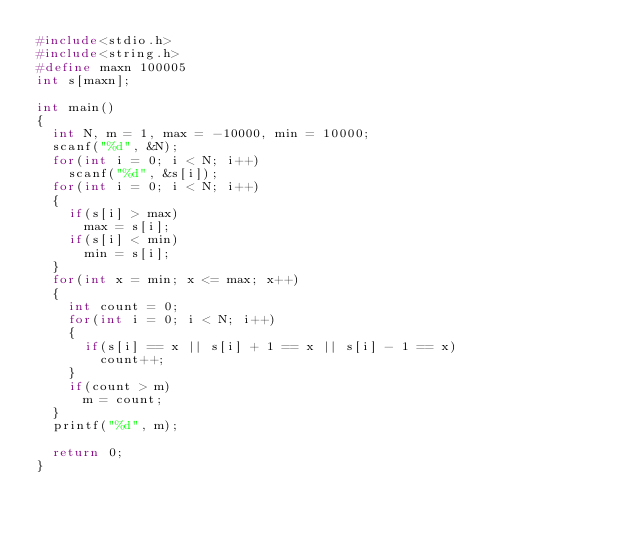<code> <loc_0><loc_0><loc_500><loc_500><_C_>#include<stdio.h>
#include<string.h>
#define maxn 100005
int s[maxn];

int main()
{
	int N, m = 1, max = -10000, min = 10000;
	scanf("%d", &N);
	for(int i = 0; i < N; i++)
		scanf("%d", &s[i]);
	for(int i = 0; i < N; i++)
	{
		if(s[i] > max)
			max = s[i];
		if(s[i] < min)
			min = s[i];
	}
	for(int x = min; x <= max; x++)
	{
		int count = 0;
		for(int i = 0; i < N; i++)
		{
			if(s[i] == x || s[i] + 1 == x || s[i] - 1 == x)
				count++;
		}
		if(count > m)
			m = count;
	}
	printf("%d", m);
	
	return 0;
}</code> 